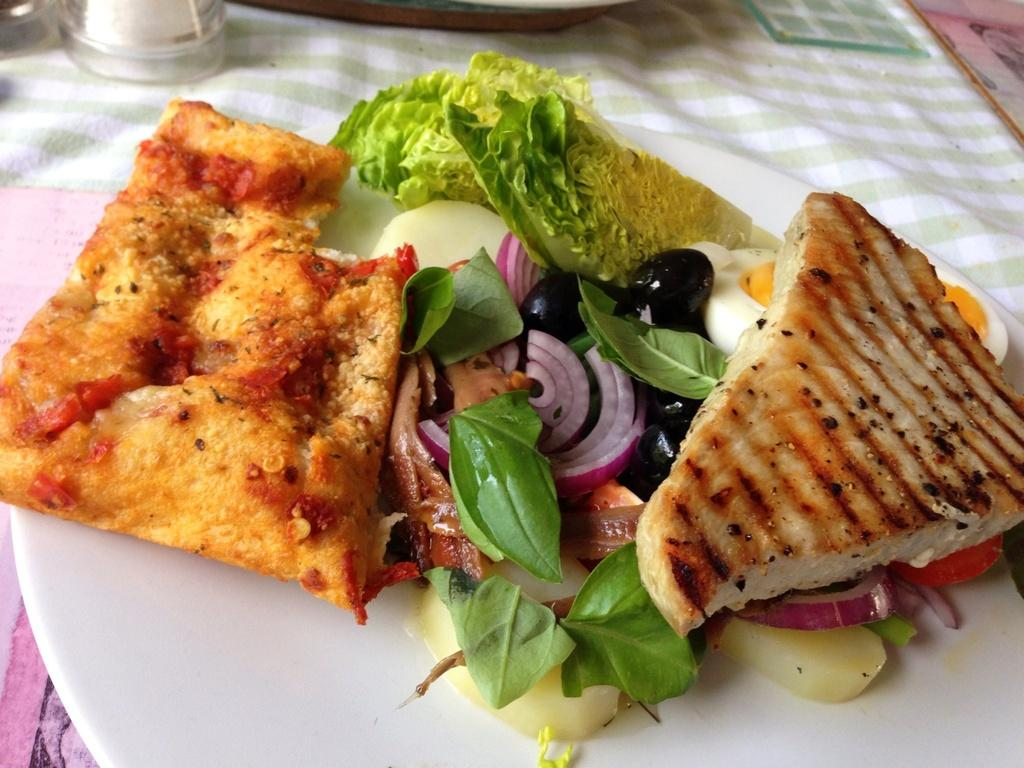What is on the plate that is visible in the image? There is food on a plate in the image. What can be seen in the background of the image? There is a glass and an object in the background of the image. What is covering the table at the bottom of the image? There is cloth on the table at the bottom of the image. What type of operation is being performed on the chin in the image? There is no operation or chin present in the image. 